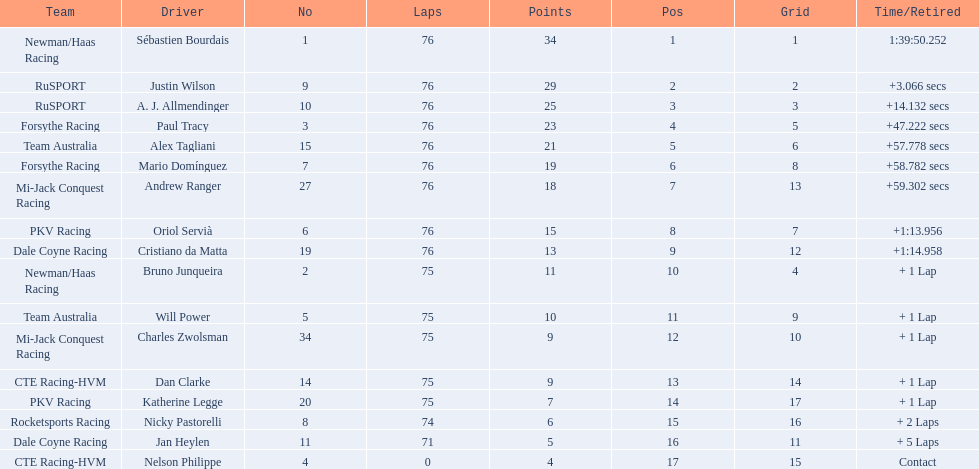What drivers took part in the 2006 tecate grand prix of monterrey? Sébastien Bourdais, Justin Wilson, A. J. Allmendinger, Paul Tracy, Alex Tagliani, Mario Domínguez, Andrew Ranger, Oriol Servià, Cristiano da Matta, Bruno Junqueira, Will Power, Charles Zwolsman, Dan Clarke, Katherine Legge, Nicky Pastorelli, Jan Heylen, Nelson Philippe. Which of those drivers scored the same amount of points as another driver? Charles Zwolsman, Dan Clarke. Who had the same amount of points as charles zwolsman? Dan Clarke. 